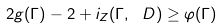<formula> <loc_0><loc_0><loc_500><loc_500>2 g ( \Gamma ) - 2 + i _ { Z } ( \Gamma , \ D ) \geq \varphi ( \Gamma )</formula> 